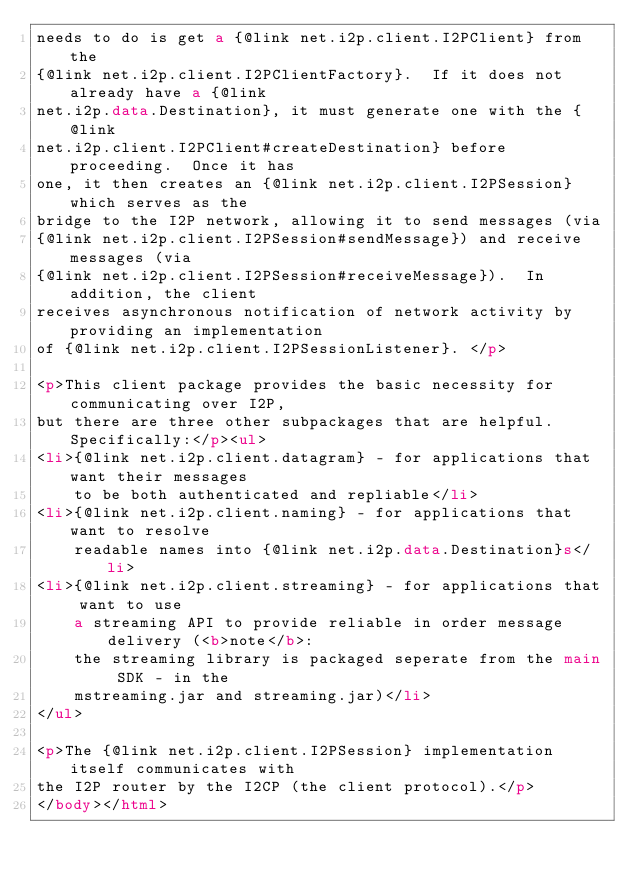<code> <loc_0><loc_0><loc_500><loc_500><_HTML_>needs to do is get a {@link net.i2p.client.I2PClient} from the 
{@link net.i2p.client.I2PClientFactory}.  If it does not already have a {@link 
net.i2p.data.Destination}, it must generate one with the {@link 
net.i2p.client.I2PClient#createDestination} before proceeding.  Once it has
one, it then creates an {@link net.i2p.client.I2PSession} which serves as the
bridge to the I2P network, allowing it to send messages (via 
{@link net.i2p.client.I2PSession#sendMessage}) and receive messages (via 
{@link net.i2p.client.I2PSession#receiveMessage}).  In addition, the client 
receives asynchronous notification of network activity by providing an implementation 
of {@link net.i2p.client.I2PSessionListener}. </p>

<p>This client package provides the basic necessity for communicating over I2P,
but there are three other subpackages that are helpful.  Specifically:</p><ul>
<li>{@link net.i2p.client.datagram} - for applications that want their messages
    to be both authenticated and repliable</li>
<li>{@link net.i2p.client.naming} - for applications that want to resolve 
    readable names into {@link net.i2p.data.Destination}s</li>
<li>{@link net.i2p.client.streaming} - for applications that want to use 
    a streaming API to provide reliable in order message delivery (<b>note</b>:
    the streaming library is packaged seperate from the main SDK - in the 
    mstreaming.jar and streaming.jar)</li>
</ul>

<p>The {@link net.i2p.client.I2PSession} implementation itself communicates with
the I2P router by the I2CP (the client protocol).</p>
</body></html>
</code> 